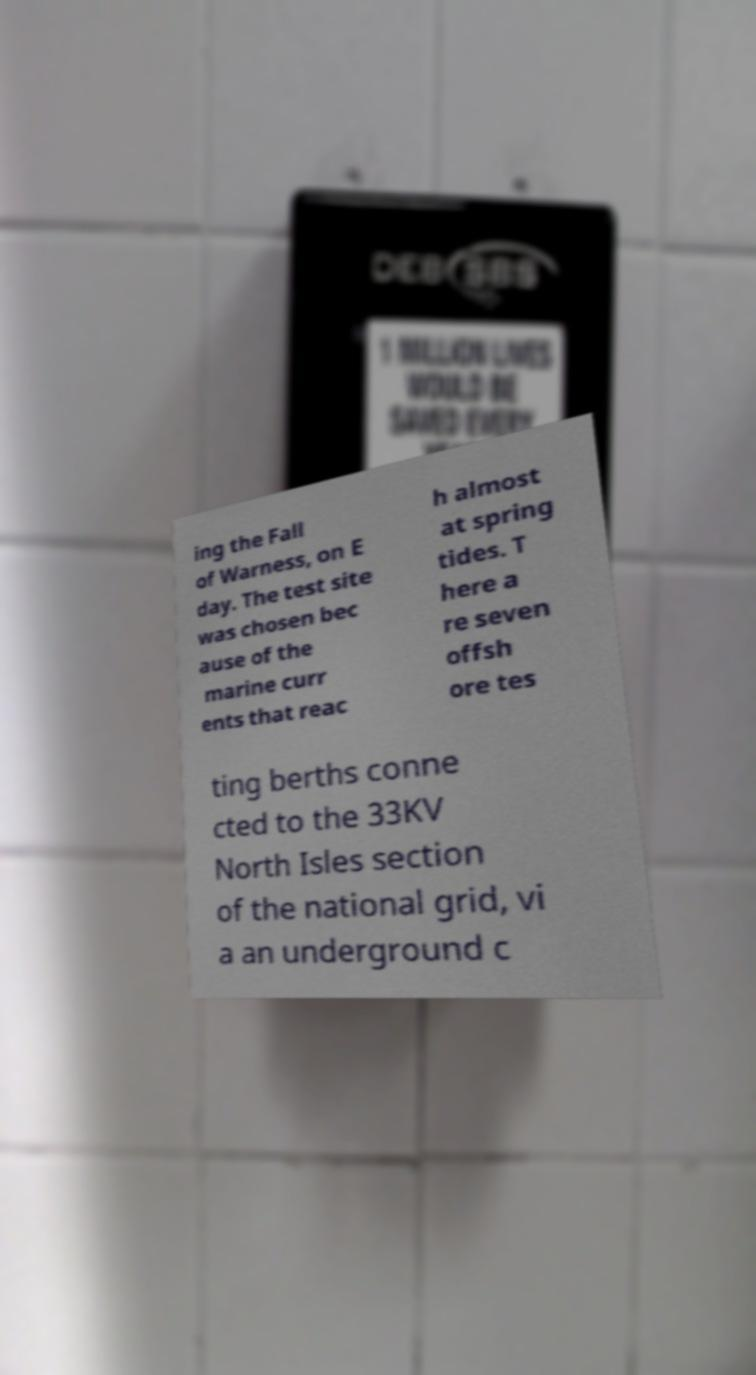I need the written content from this picture converted into text. Can you do that? ing the Fall of Warness, on E day. The test site was chosen bec ause of the marine curr ents that reac h almost at spring tides. T here a re seven offsh ore tes ting berths conne cted to the 33KV North Isles section of the national grid, vi a an underground c 